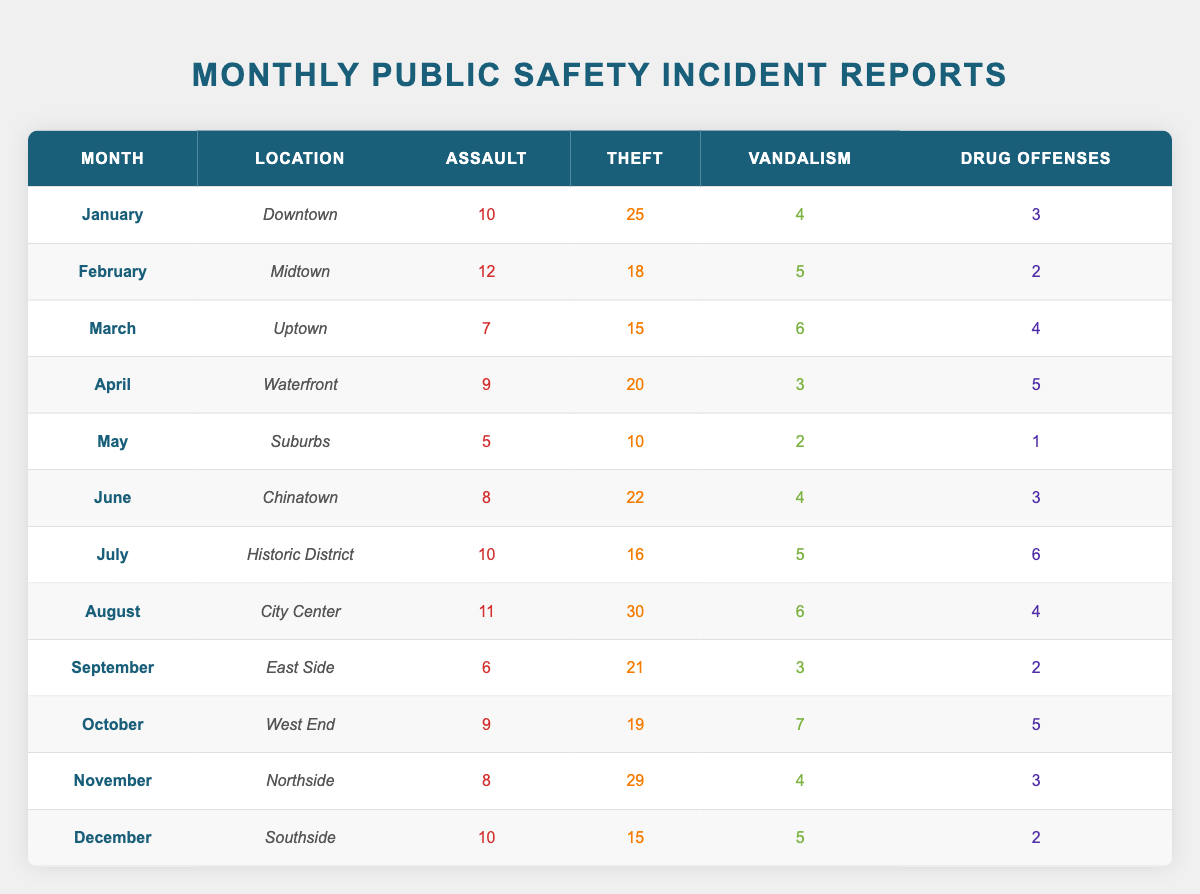What was the highest number of theft incidents in a single month? To find the highest number of theft incidents, I need to look through the theft column for all months. The values are: 25 (January), 18 (February), 15 (March), 20 (April), 10 (May), 22 (June), 16 (July), 30 (August), 21 (September), 19 (October), 29 (November), and 15 (December). The maximum value is 30 from August.
Answer: 30 In which location did the most assaults occur in January? The table shows that in January the location was Downtown, where there were 10 assaults. The question specifically asks for the number of assaults and the location for that month. Therefore, the answer is Downtown.
Answer: Downtown What is the total number of drug offenses reported across all months? To calculate the total number of drug offenses, I must add the values from the drug offenses column: 3 (January) + 2 (February) + 4 (March) + 5 (April) + 1 (May) + 3 (June) + 6 (July) + 4 (August) + 2 (September) + 5 (October) + 3 (November) + 2 (December). The total sum is 3 + 2 + 4 + 5 + 1 + 3 + 6 + 4 + 2 + 5 + 3 + 2 = 42.
Answer: 42 Did the Waterfront have more thefts or assaults in April? In April, the Waterfront had 20 thefts and 9 assaults. To determine whether there were more thefts or assaults, we can compare the two numbers directly. Since 20 (thefts) is greater than 9 (assaults), the answer is yes, there were more thefts.
Answer: Yes What month had the least total incidents if we combine assaults, thefts, vandalism, and drug offenses? To find the month with the least total incidents, I will calculate the sum of all four types of incidents for each month: January (10 + 25 + 4 + 3 = 42), February (12 + 18 + 5 + 2 = 37), March (7 + 15 + 6 + 4 = 32), April (9 + 20 + 3 + 5 = 37), May (5 + 10 + 2 + 1 = 18), June (8 + 22 + 4 + 3 = 37), July (10 + 16 + 5 + 6 = 37), August (11 + 30 + 6 + 4 = 51), September (6 + 21 + 3 + 2 = 32), October (9 + 19 + 7 + 5 = 40), November (8 + 29 + 4 + 3 = 44), December (10 + 15 + 5 + 2 = 32). The minimum total is 18 in May.
Answer: May 